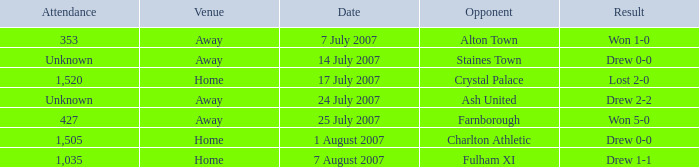Name the attendance with result of won 1-0 353.0. 